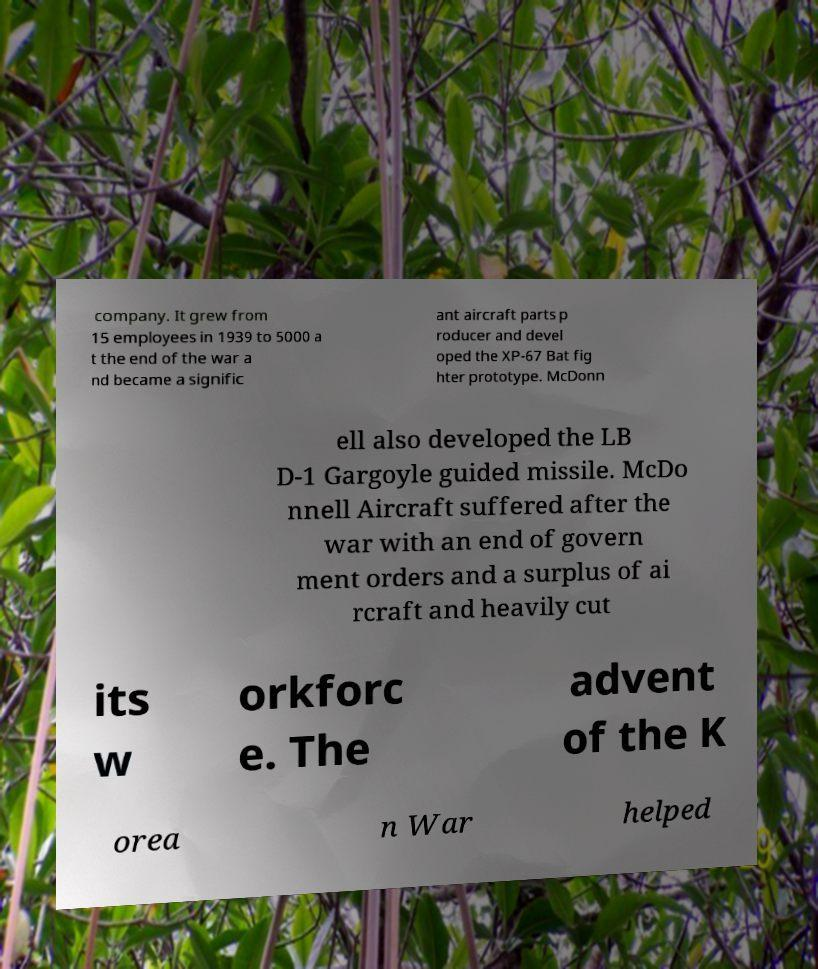What messages or text are displayed in this image? I need them in a readable, typed format. company. It grew from 15 employees in 1939 to 5000 a t the end of the war a nd became a signific ant aircraft parts p roducer and devel oped the XP-67 Bat fig hter prototype. McDonn ell also developed the LB D-1 Gargoyle guided missile. McDo nnell Aircraft suffered after the war with an end of govern ment orders and a surplus of ai rcraft and heavily cut its w orkforc e. The advent of the K orea n War helped 